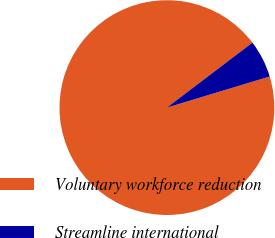Convert chart. <chart><loc_0><loc_0><loc_500><loc_500><pie_chart><fcel>Voluntary workforce reduction<fcel>Streamline international<nl><fcel>94.34%<fcel>5.66%<nl></chart> 